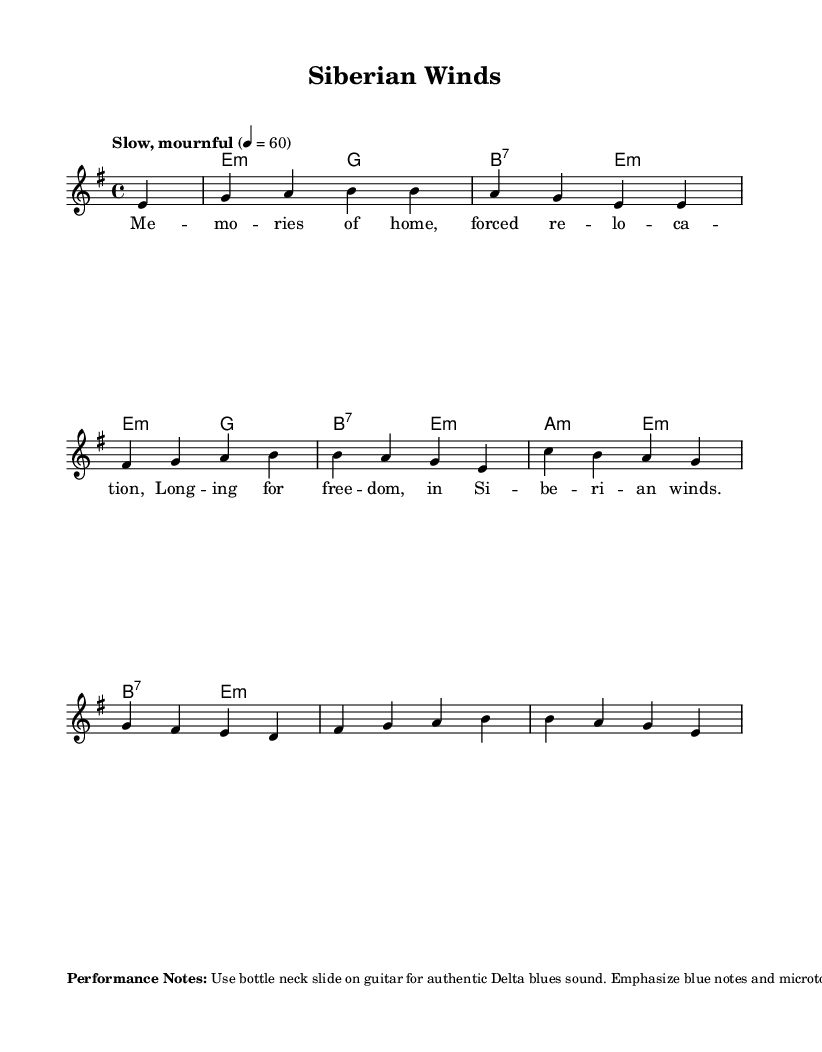What is the key signature of this music? The key signature is E minor, which contains one sharp (F#). This can be identified by looking at the key signature section in the beginning of the sheet music, which indicates the presence of one sharp.
Answer: E minor What is the time signature of this music? The time signature is 4/4, indicated at the beginning of the sheet music next to the key signature. This means there are four beats in each measure, and the quarter note gets one beat.
Answer: 4/4 What is the tempo marking for the piece? The tempo marking is "Slow, mournful," which describes the feel and speed at which the music should be performed. This is also specified at the beginning of the sheet music.
Answer: Slow, mournful How many measures are in the melody? There are eight measures in the melody as indicated by the layout of the notes and phrases in the score. Each group of notes corresponds to a measure, which can be counted visually.
Answer: 8 What type of chord is used on the first measure? The first measure uses an E minor chord, as indicated by the chord symbol "e:m" placed above the corresponding melody notes. This identifies the harmony for that specific measure.
Answer: E minor What specific instrument technique is suggested for performance? The sheet music suggests using a bottle neck slide on the guitar to achieve an authentic Delta blues sound. This performance note is provided in the markup section below the score.
Answer: Bottle neck slide What do the phrases in the lyrics convey in this blues piece? The lyrics convey themes of nostalgia and longing, expressing feelings related to exile and the desire for freedom. This interpretation comes from analyzing the words and sentiments reflected in the provided lyrical content.
Answer: Nostalgia and longing 